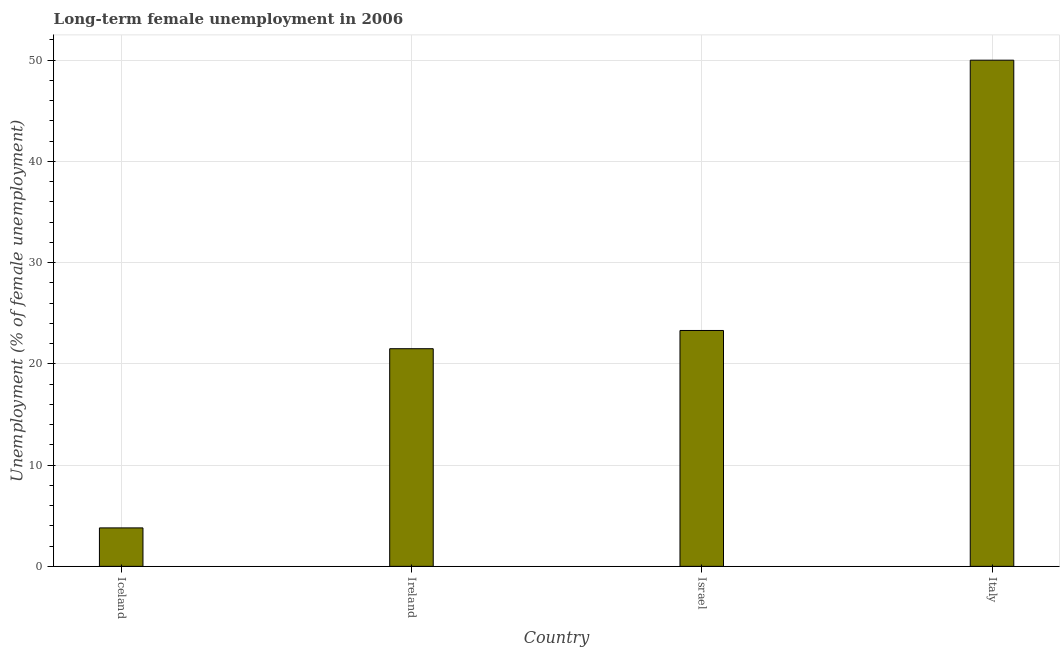Does the graph contain grids?
Offer a terse response. Yes. What is the title of the graph?
Give a very brief answer. Long-term female unemployment in 2006. What is the label or title of the Y-axis?
Your answer should be compact. Unemployment (% of female unemployment). What is the long-term female unemployment in Iceland?
Keep it short and to the point. 3.8. Across all countries, what is the minimum long-term female unemployment?
Ensure brevity in your answer.  3.8. What is the sum of the long-term female unemployment?
Offer a terse response. 98.6. What is the difference between the long-term female unemployment in Iceland and Ireland?
Give a very brief answer. -17.7. What is the average long-term female unemployment per country?
Give a very brief answer. 24.65. What is the median long-term female unemployment?
Your response must be concise. 22.4. In how many countries, is the long-term female unemployment greater than 34 %?
Offer a very short reply. 1. What is the ratio of the long-term female unemployment in Israel to that in Italy?
Your answer should be very brief. 0.47. What is the difference between the highest and the second highest long-term female unemployment?
Keep it short and to the point. 26.7. What is the difference between the highest and the lowest long-term female unemployment?
Provide a short and direct response. 46.2. In how many countries, is the long-term female unemployment greater than the average long-term female unemployment taken over all countries?
Provide a short and direct response. 1. Are all the bars in the graph horizontal?
Ensure brevity in your answer.  No. What is the difference between two consecutive major ticks on the Y-axis?
Offer a terse response. 10. What is the Unemployment (% of female unemployment) in Iceland?
Offer a very short reply. 3.8. What is the Unemployment (% of female unemployment) of Israel?
Provide a short and direct response. 23.3. What is the Unemployment (% of female unemployment) of Italy?
Your response must be concise. 50. What is the difference between the Unemployment (% of female unemployment) in Iceland and Ireland?
Your response must be concise. -17.7. What is the difference between the Unemployment (% of female unemployment) in Iceland and Israel?
Ensure brevity in your answer.  -19.5. What is the difference between the Unemployment (% of female unemployment) in Iceland and Italy?
Offer a terse response. -46.2. What is the difference between the Unemployment (% of female unemployment) in Ireland and Israel?
Provide a succinct answer. -1.8. What is the difference between the Unemployment (% of female unemployment) in Ireland and Italy?
Provide a short and direct response. -28.5. What is the difference between the Unemployment (% of female unemployment) in Israel and Italy?
Provide a short and direct response. -26.7. What is the ratio of the Unemployment (% of female unemployment) in Iceland to that in Ireland?
Provide a short and direct response. 0.18. What is the ratio of the Unemployment (% of female unemployment) in Iceland to that in Israel?
Your answer should be compact. 0.16. What is the ratio of the Unemployment (% of female unemployment) in Iceland to that in Italy?
Keep it short and to the point. 0.08. What is the ratio of the Unemployment (% of female unemployment) in Ireland to that in Israel?
Ensure brevity in your answer.  0.92. What is the ratio of the Unemployment (% of female unemployment) in Ireland to that in Italy?
Keep it short and to the point. 0.43. What is the ratio of the Unemployment (% of female unemployment) in Israel to that in Italy?
Offer a terse response. 0.47. 